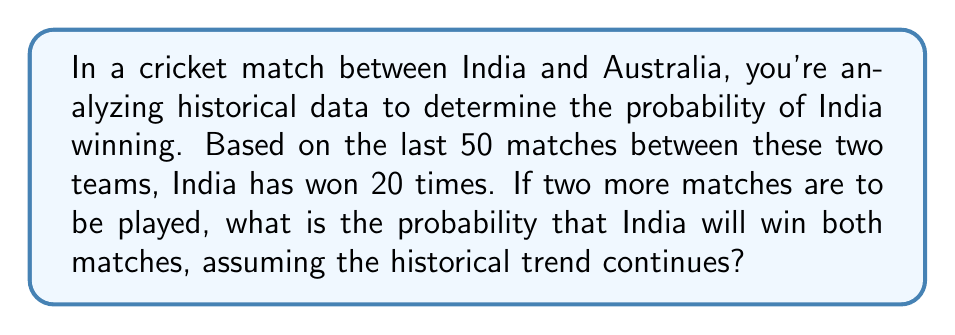Give your solution to this math problem. Let's approach this step-by-step:

1) First, we need to determine the probability of India winning a single match based on the historical data.

   $P(\text{India wins}) = \frac{\text{Number of India's wins}}{\text{Total number of matches}}$

   $P(\text{India wins}) = \frac{20}{50} = 0.4$ or $40\%$

2) Now, we need to calculate the probability of India winning both matches. Since we assume the historical trend continues, these are independent events.

3) For independent events, the probability of both events occurring is the product of their individual probabilities.

   $P(\text{India wins both}) = P(\text{India wins 1st}) \times P(\text{India wins 2nd})$

4) Substituting the probability we calculated in step 1:

   $P(\text{India wins both}) = 0.4 \times 0.4 = 0.16$

5) To convert to a percentage:

   $0.16 \times 100\% = 16\%$

Therefore, based on the historical data, the probability that India will win both upcoming matches is 16% or 0.16.
Answer: The probability that India will win both matches is $0.16$ or $16\%$. 